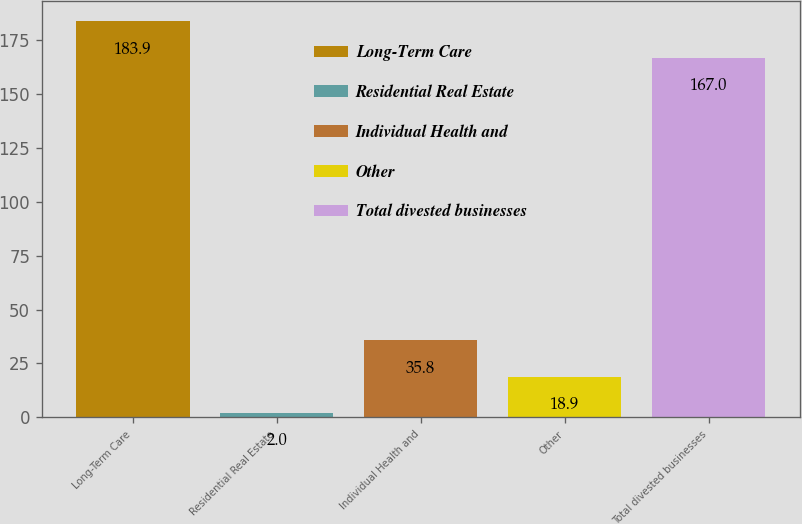Convert chart to OTSL. <chart><loc_0><loc_0><loc_500><loc_500><bar_chart><fcel>Long-Term Care<fcel>Residential Real Estate<fcel>Individual Health and<fcel>Other<fcel>Total divested businesses<nl><fcel>183.9<fcel>2<fcel>35.8<fcel>18.9<fcel>167<nl></chart> 